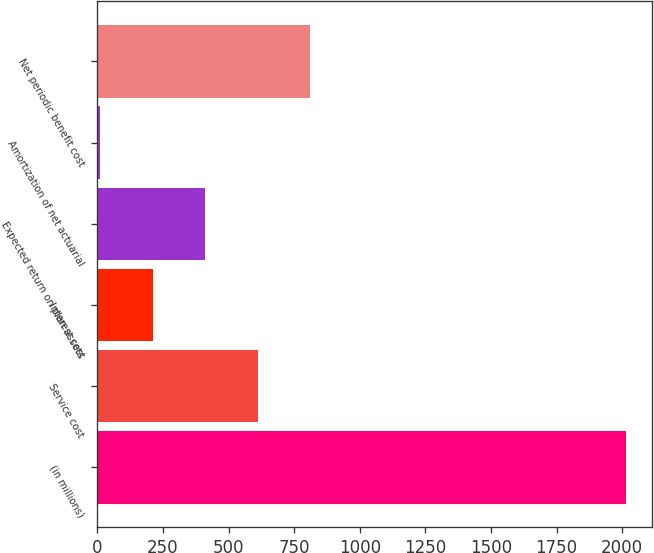Convert chart to OTSL. <chart><loc_0><loc_0><loc_500><loc_500><bar_chart><fcel>(in millions)<fcel>Service cost<fcel>Interest cost<fcel>Expected return on plan assets<fcel>Amortization of net actuarial<fcel>Net periodic benefit cost<nl><fcel>2014<fcel>611.9<fcel>211.3<fcel>411.6<fcel>11<fcel>812.2<nl></chart> 